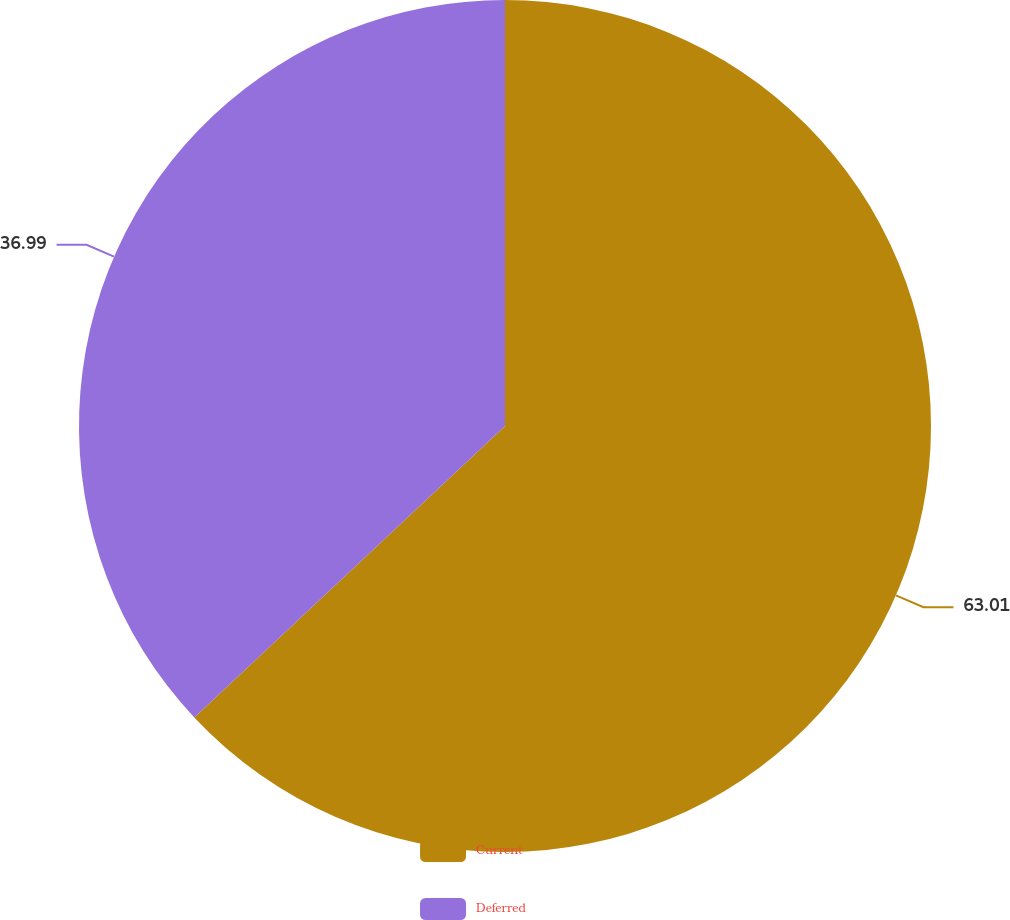Convert chart. <chart><loc_0><loc_0><loc_500><loc_500><pie_chart><fcel>Current<fcel>Deferred<nl><fcel>63.01%<fcel>36.99%<nl></chart> 